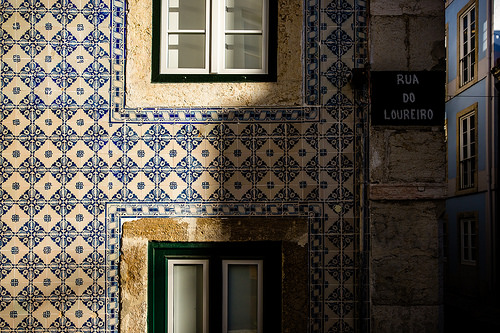<image>
Is there a wall behind the window? No. The wall is not behind the window. From this viewpoint, the wall appears to be positioned elsewhere in the scene. 